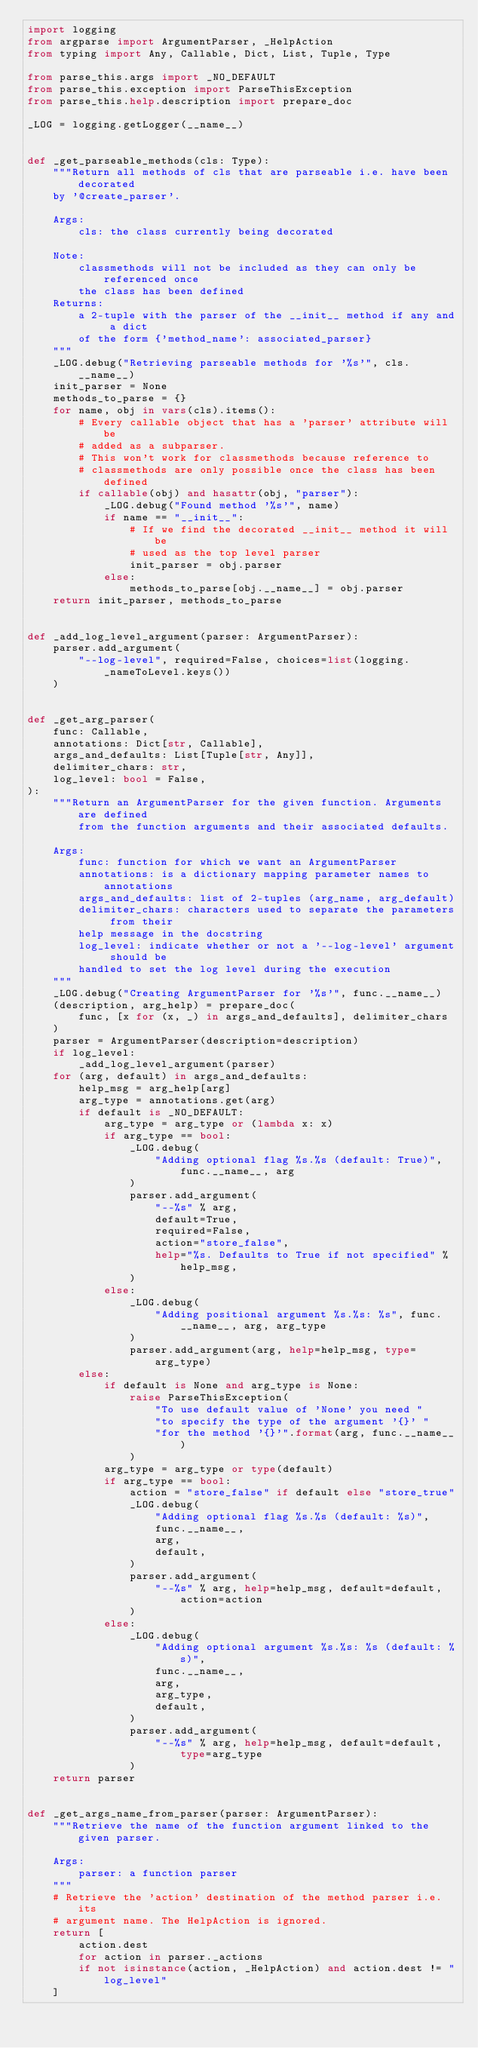Convert code to text. <code><loc_0><loc_0><loc_500><loc_500><_Python_>import logging
from argparse import ArgumentParser, _HelpAction
from typing import Any, Callable, Dict, List, Tuple, Type

from parse_this.args import _NO_DEFAULT
from parse_this.exception import ParseThisException
from parse_this.help.description import prepare_doc

_LOG = logging.getLogger(__name__)


def _get_parseable_methods(cls: Type):
    """Return all methods of cls that are parseable i.e. have been decorated
    by '@create_parser'.

    Args:
        cls: the class currently being decorated

    Note:
        classmethods will not be included as they can only be referenced once
        the class has been defined
    Returns:
        a 2-tuple with the parser of the __init__ method if any and a dict
        of the form {'method_name': associated_parser}
    """
    _LOG.debug("Retrieving parseable methods for '%s'", cls.__name__)
    init_parser = None
    methods_to_parse = {}
    for name, obj in vars(cls).items():
        # Every callable object that has a 'parser' attribute will be
        # added as a subparser.
        # This won't work for classmethods because reference to
        # classmethods are only possible once the class has been defined
        if callable(obj) and hasattr(obj, "parser"):
            _LOG.debug("Found method '%s'", name)
            if name == "__init__":
                # If we find the decorated __init__ method it will be
                # used as the top level parser
                init_parser = obj.parser
            else:
                methods_to_parse[obj.__name__] = obj.parser
    return init_parser, methods_to_parse


def _add_log_level_argument(parser: ArgumentParser):
    parser.add_argument(
        "--log-level", required=False, choices=list(logging._nameToLevel.keys())
    )


def _get_arg_parser(
    func: Callable,
    annotations: Dict[str, Callable],
    args_and_defaults: List[Tuple[str, Any]],
    delimiter_chars: str,
    log_level: bool = False,
):
    """Return an ArgumentParser for the given function. Arguments are defined
        from the function arguments and their associated defaults.

    Args:
        func: function for which we want an ArgumentParser
        annotations: is a dictionary mapping parameter names to annotations
        args_and_defaults: list of 2-tuples (arg_name, arg_default)
        delimiter_chars: characters used to separate the parameters from their
        help message in the docstring
        log_level: indicate whether or not a '--log-level' argument should be
        handled to set the log level during the execution
    """
    _LOG.debug("Creating ArgumentParser for '%s'", func.__name__)
    (description, arg_help) = prepare_doc(
        func, [x for (x, _) in args_and_defaults], delimiter_chars
    )
    parser = ArgumentParser(description=description)
    if log_level:
        _add_log_level_argument(parser)
    for (arg, default) in args_and_defaults:
        help_msg = arg_help[arg]
        arg_type = annotations.get(arg)
        if default is _NO_DEFAULT:
            arg_type = arg_type or (lambda x: x)
            if arg_type == bool:
                _LOG.debug(
                    "Adding optional flag %s.%s (default: True)", func.__name__, arg
                )
                parser.add_argument(
                    "--%s" % arg,
                    default=True,
                    required=False,
                    action="store_false",
                    help="%s. Defaults to True if not specified" % help_msg,
                )
            else:
                _LOG.debug(
                    "Adding positional argument %s.%s: %s", func.__name__, arg, arg_type
                )
                parser.add_argument(arg, help=help_msg, type=arg_type)
        else:
            if default is None and arg_type is None:
                raise ParseThisException(
                    "To use default value of 'None' you need "
                    "to specify the type of the argument '{}' "
                    "for the method '{}'".format(arg, func.__name__)
                )
            arg_type = arg_type or type(default)
            if arg_type == bool:
                action = "store_false" if default else "store_true"
                _LOG.debug(
                    "Adding optional flag %s.%s (default: %s)",
                    func.__name__,
                    arg,
                    default,
                )
                parser.add_argument(
                    "--%s" % arg, help=help_msg, default=default, action=action
                )
            else:
                _LOG.debug(
                    "Adding optional argument %s.%s: %s (default: %s)",
                    func.__name__,
                    arg,
                    arg_type,
                    default,
                )
                parser.add_argument(
                    "--%s" % arg, help=help_msg, default=default, type=arg_type
                )
    return parser


def _get_args_name_from_parser(parser: ArgumentParser):
    """Retrieve the name of the function argument linked to the given parser.

    Args:
        parser: a function parser
    """
    # Retrieve the 'action' destination of the method parser i.e. its
    # argument name. The HelpAction is ignored.
    return [
        action.dest
        for action in parser._actions
        if not isinstance(action, _HelpAction) and action.dest != "log_level"
    ]
</code> 